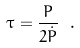<formula> <loc_0><loc_0><loc_500><loc_500>\tau = \frac { P } { 2 \dot { P } } \ .</formula> 